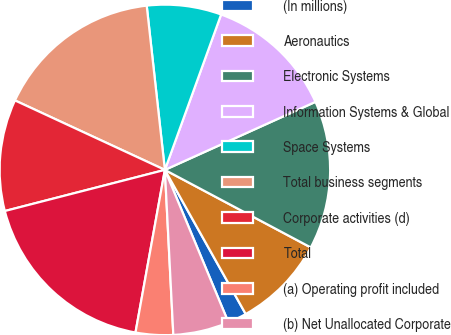Convert chart. <chart><loc_0><loc_0><loc_500><loc_500><pie_chart><fcel>(In millions)<fcel>Aeronautics<fcel>Electronic Systems<fcel>Information Systems & Global<fcel>Space Systems<fcel>Total business segments<fcel>Corporate activities (d)<fcel>Total<fcel>(a) Operating profit included<fcel>(b) Net Unallocated Corporate<nl><fcel>1.85%<fcel>9.09%<fcel>14.53%<fcel>12.72%<fcel>7.28%<fcel>16.34%<fcel>10.91%<fcel>18.15%<fcel>3.66%<fcel>5.47%<nl></chart> 